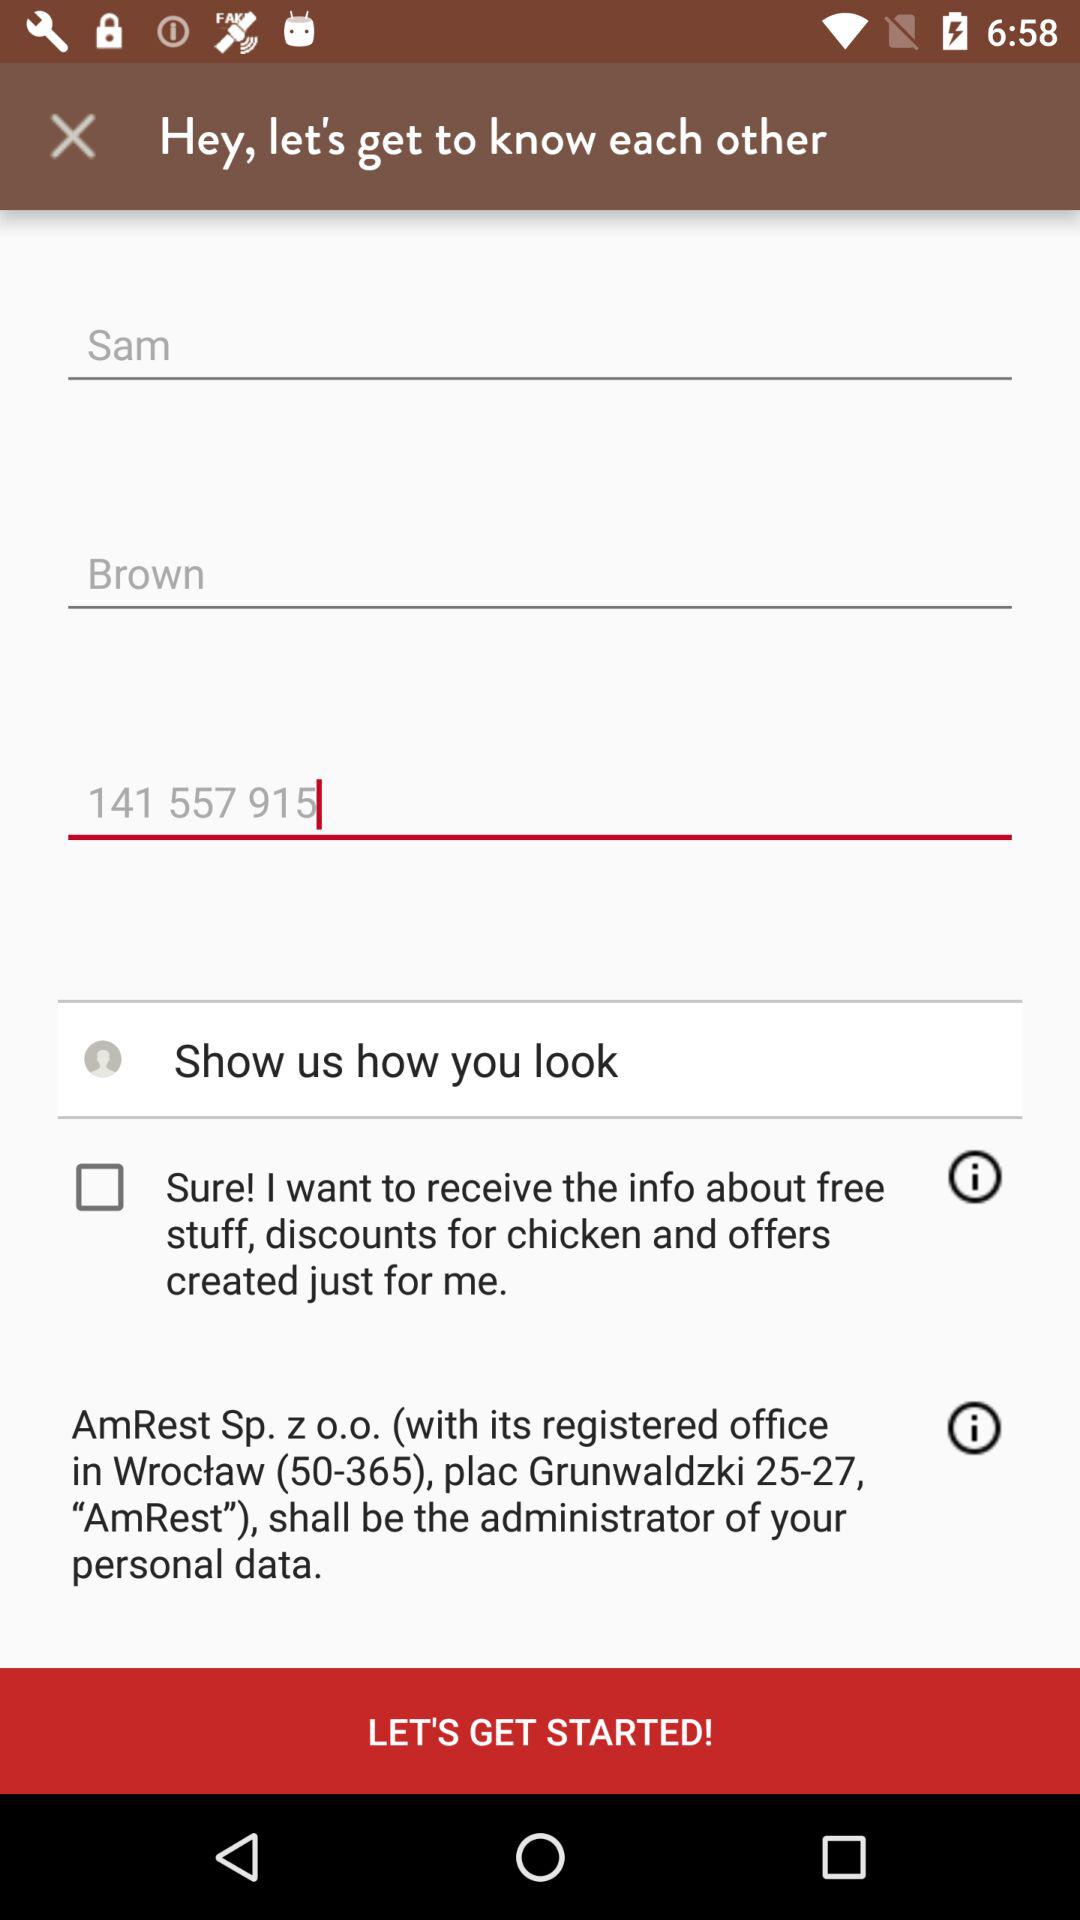What is the user name? The user name is Sam Brown. 